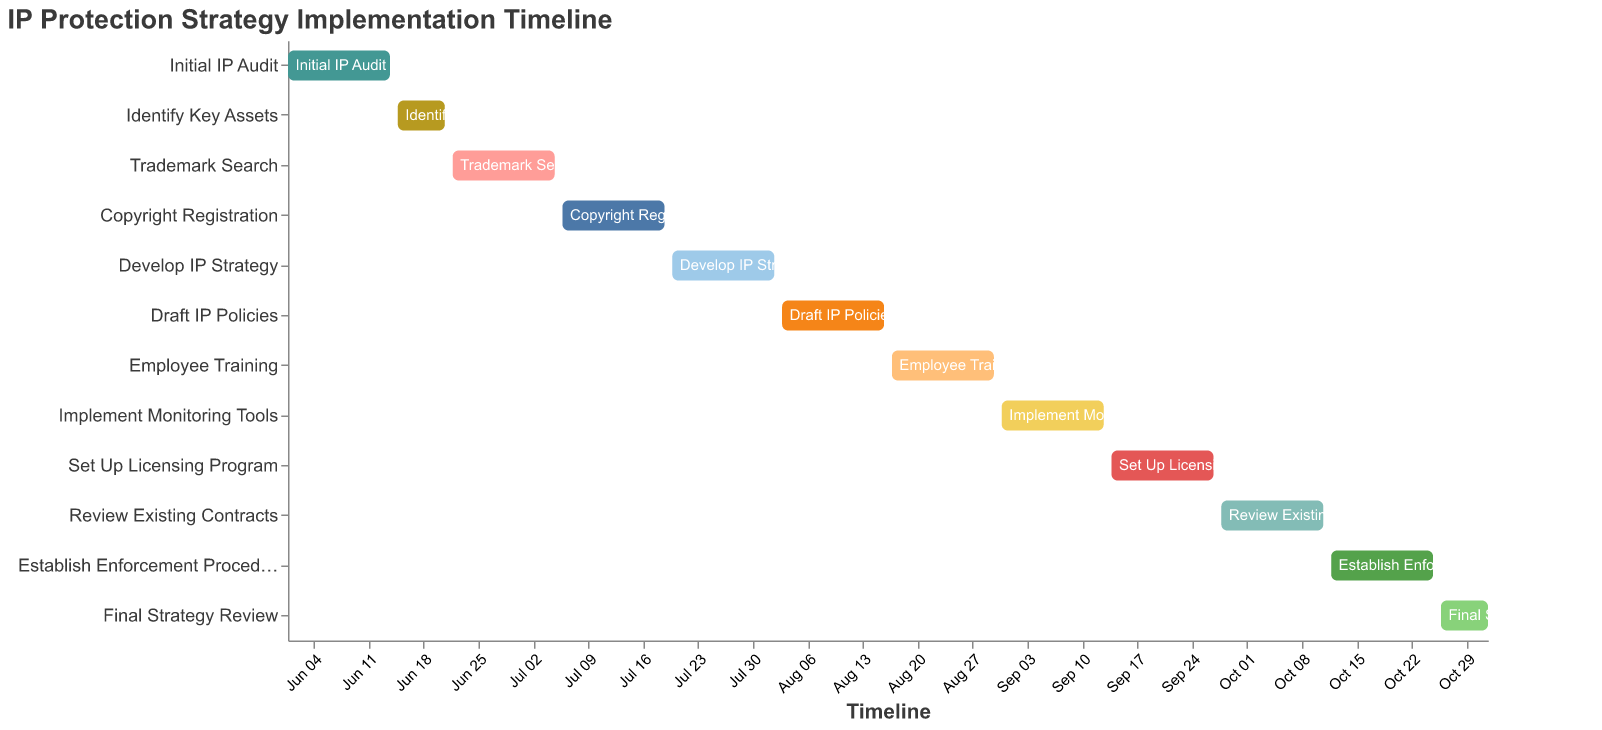What is the title of the Gantt Chart? The title usually appears at the top of a chart and summarizes the chart's main subject. Here, the title text is "IP Protection Strategy Implementation Timeline," which summarizes the project management focus for implementing an intellectual property protection strategy.
Answer: IP Protection Strategy Implementation Timeline Which task starts immediately after "Initial IP Audit"? The "Initial IP Audit" starts on June 1 and ends on June 14. The next task that starts immediately on June 15 is "Identify Key Assets," as indicated by the start date in the Gantt chart.
Answer: Identify Key Assets What is the duration of the "Employee Training" task? "Employee Training" starts on August 17 and ends on August 30. The duration is labeled as 14 days in the chart.
Answer: 14 days How many tasks have a duration of 7 days? By inspecting the duration column and corresponding bars in the Gantt Chart, the tasks with a 7-day duration are "Identify Key Assets" and "Final Strategy Review."
Answer: 2 tasks When does the "Final Strategy Review" task end? The "Final Strategy Review" task starts on October 26 and ends on November 1, as indicated in the chart.
Answer: November 1 Which task has the longest duration, and what is its duration? By examining the duration for each task, the majority of tasks have a duration of 14 days. No tasks exceed this duration. Therefore, there is a tie for the longest duration of 14 days, but the task itself is typical, like "Initial IP Audit."
Answer: Initial IP Audit (14 days) Which tasks are scheduled to be completed by the end of August? Reviewing the end dates, the tasks completed by the end of August are "Initial IP Audit", "Identify Key Assets", "Trademark Search", "Copyright Registration", "Develop IP Strategy", "Draft IP Policies," and "Employee Training."
Answer: Employee Training What is the total duration for "Implement Monitoring Tools" and "Set Up Licensing Program" combined? The duration for "Implement Monitoring Tools" is 14 days, and "Set Up Licensing Program" is also 14 days. Summing these durations gives 14 + 14 = 28 days.
Answer: 28 days Which task directly follows "Copyright Registration"? The "Copyright Registration" task ends on July 19. The task starting immediately after that, on July 20, is "Develop IP Strategy," as indicated in the Gantt Chart.
Answer: Develop IP Strategy 